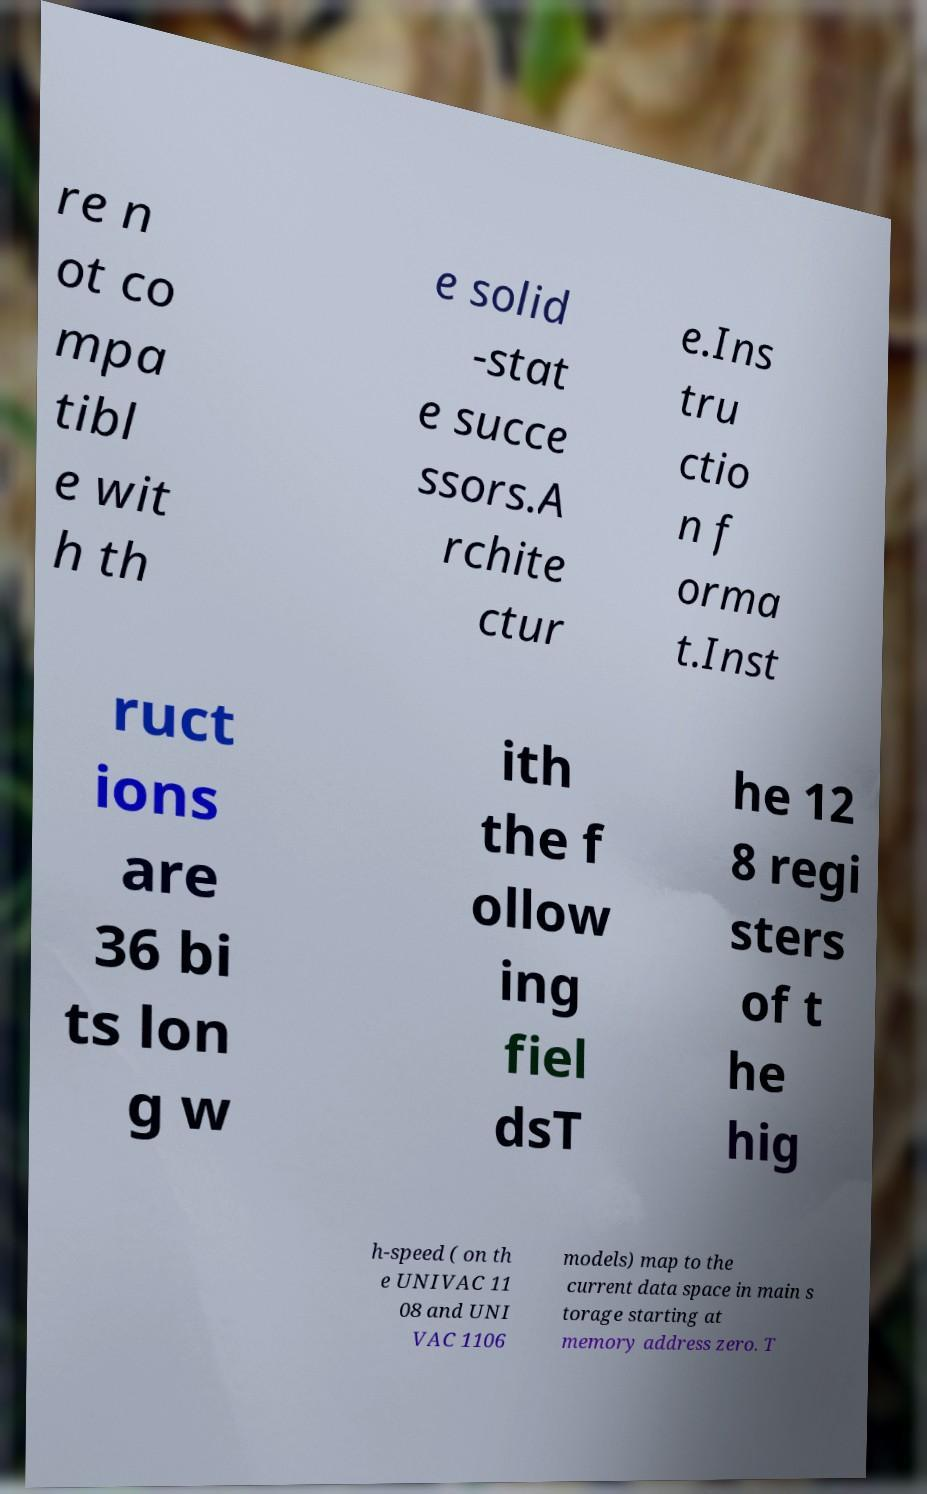Could you extract and type out the text from this image? re n ot co mpa tibl e wit h th e solid -stat e succe ssors.A rchite ctur e.Ins tru ctio n f orma t.Inst ruct ions are 36 bi ts lon g w ith the f ollow ing fiel dsT he 12 8 regi sters of t he hig h-speed ( on th e UNIVAC 11 08 and UNI VAC 1106 models) map to the current data space in main s torage starting at memory address zero. T 